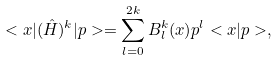Convert formula to latex. <formula><loc_0><loc_0><loc_500><loc_500>< x | ( \hat { H } ) ^ { k } | p > = \sum _ { l = 0 } ^ { 2 k } B _ { l } ^ { k } ( x ) p ^ { l } < x | p > ,</formula> 